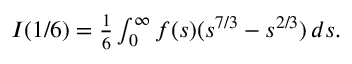Convert formula to latex. <formula><loc_0><loc_0><loc_500><loc_500>\begin{array} { r } { I ( 1 / 6 ) = \frac { 1 } { 6 } \int _ { 0 } ^ { \infty } f ( s ) ( s ^ { 7 / 3 } - s ^ { 2 / 3 } ) \, d s . } \end{array}</formula> 